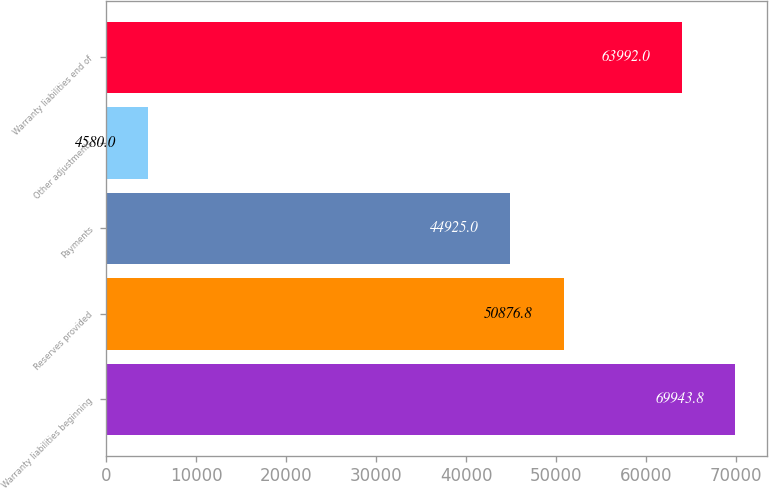Convert chart to OTSL. <chart><loc_0><loc_0><loc_500><loc_500><bar_chart><fcel>Warranty liabilities beginning<fcel>Reserves provided<fcel>Payments<fcel>Other adjustments<fcel>Warranty liabilities end of<nl><fcel>69943.8<fcel>50876.8<fcel>44925<fcel>4580<fcel>63992<nl></chart> 